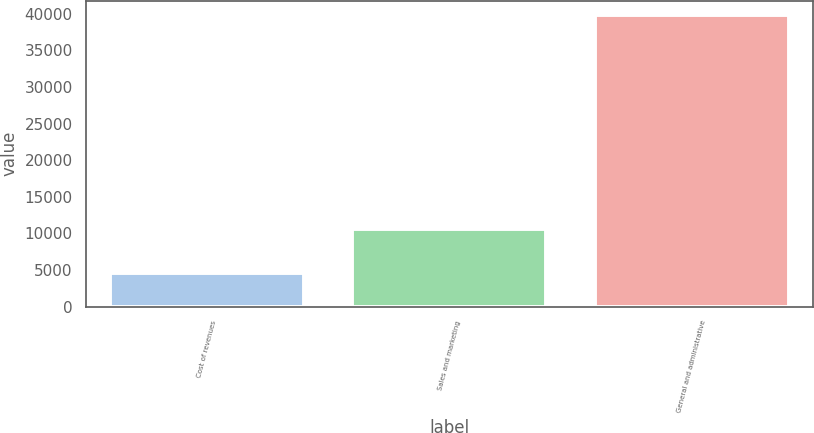Convert chart. <chart><loc_0><loc_0><loc_500><loc_500><bar_chart><fcel>Cost of revenues<fcel>Sales and marketing<fcel>General and administrative<nl><fcel>4641<fcel>10637<fcel>39807<nl></chart> 